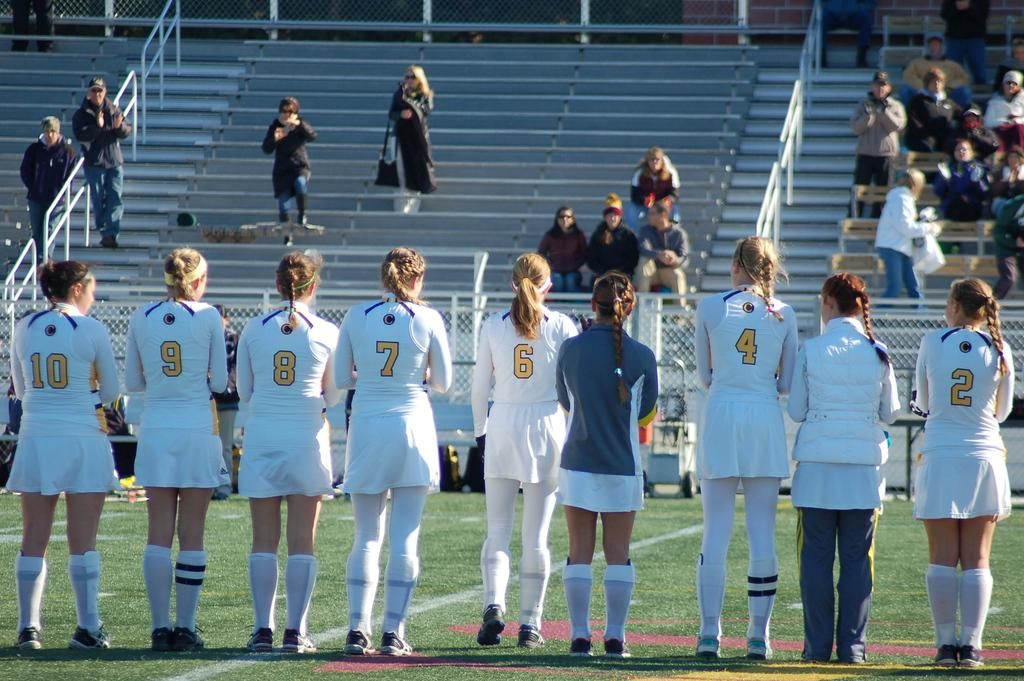<image>
Offer a succinct explanation of the picture presented. Players from a female sports team stand on a playing field and the number 2 player is on the far right. 